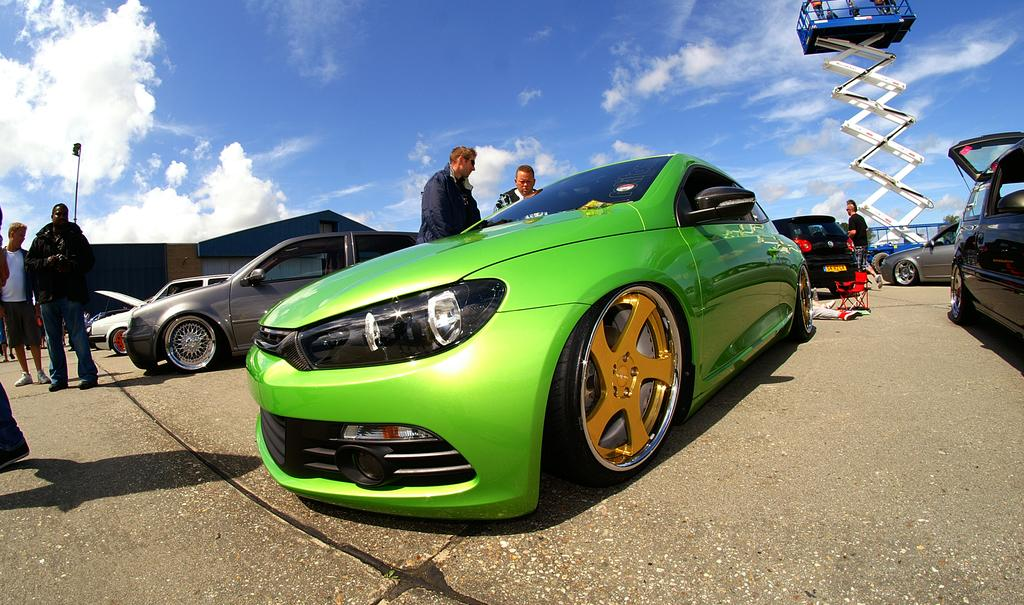What type of vehicles can be seen in the image? There are cars in the image. What are the people on the road doing? There are people standing on the road in the image. What type of building is visible in the image? There is a house in the image. What can be seen in the background of the image? The sky is visible in the background of the image. What is the weather like in the image? Clouds are present in the sky, suggesting a partly cloudy day. What type of bread is being served at the government meeting in the image? There is no government meeting or bread present in the image. What is the connection between the cars and the clouds in the image? There is no direct connection between the cars and the clouds in the image; they are separate elements in the scene. 